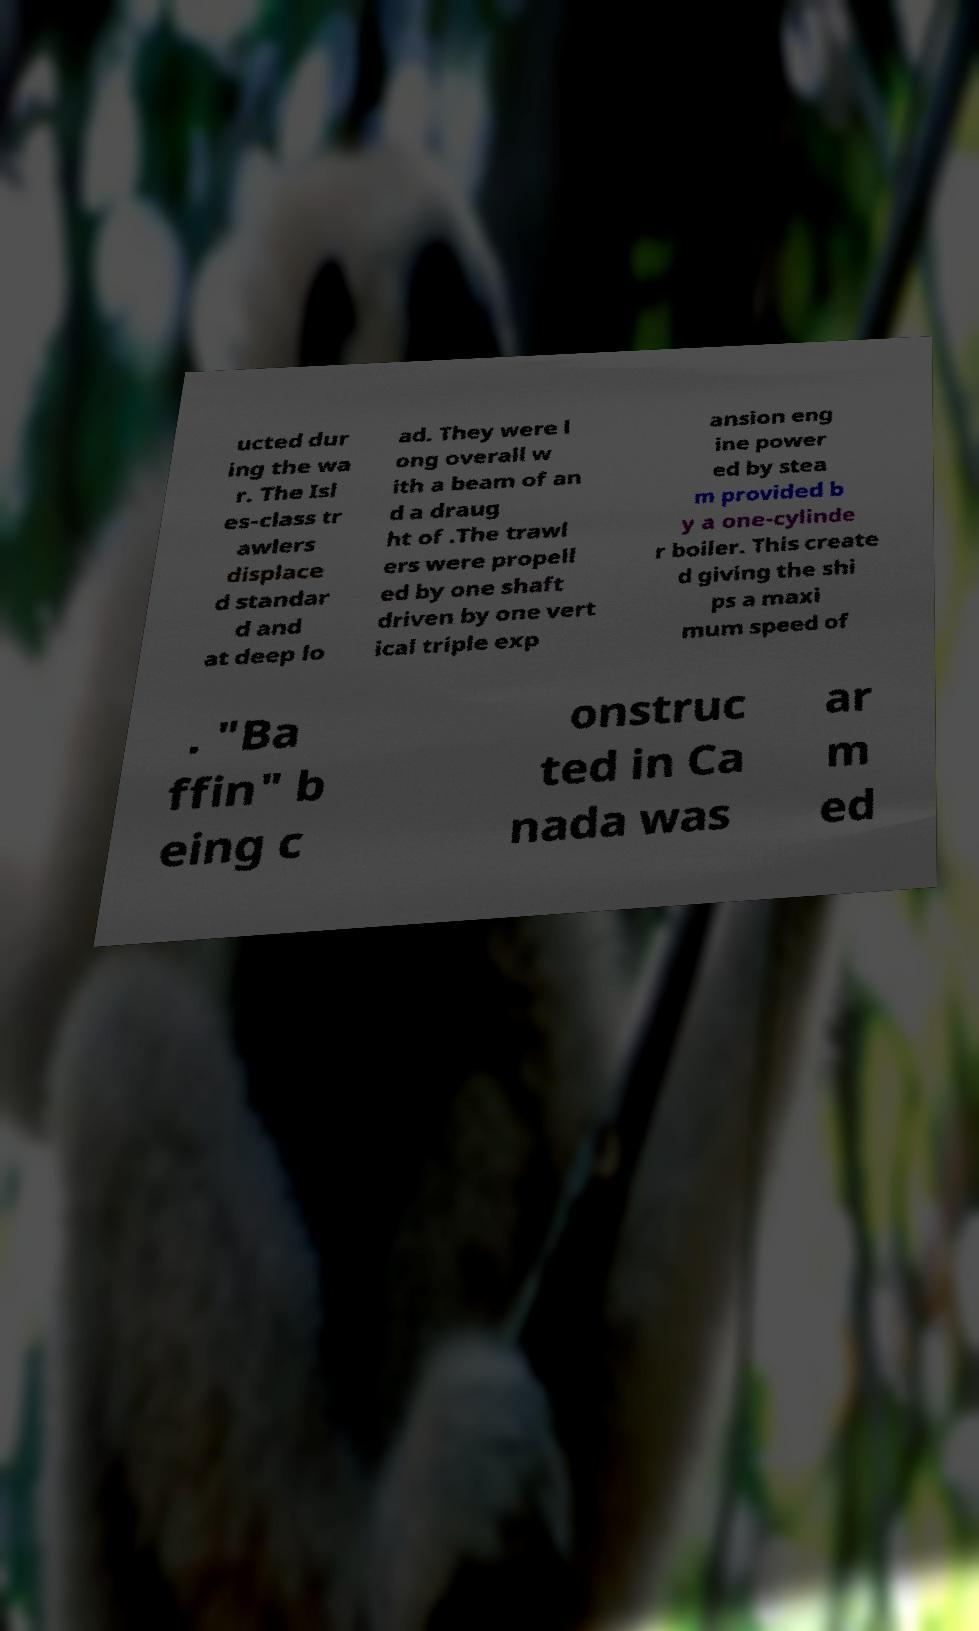For documentation purposes, I need the text within this image transcribed. Could you provide that? ucted dur ing the wa r. The Isl es-class tr awlers displace d standar d and at deep lo ad. They were l ong overall w ith a beam of an d a draug ht of .The trawl ers were propell ed by one shaft driven by one vert ical triple exp ansion eng ine power ed by stea m provided b y a one-cylinde r boiler. This create d giving the shi ps a maxi mum speed of . "Ba ffin" b eing c onstruc ted in Ca nada was ar m ed 